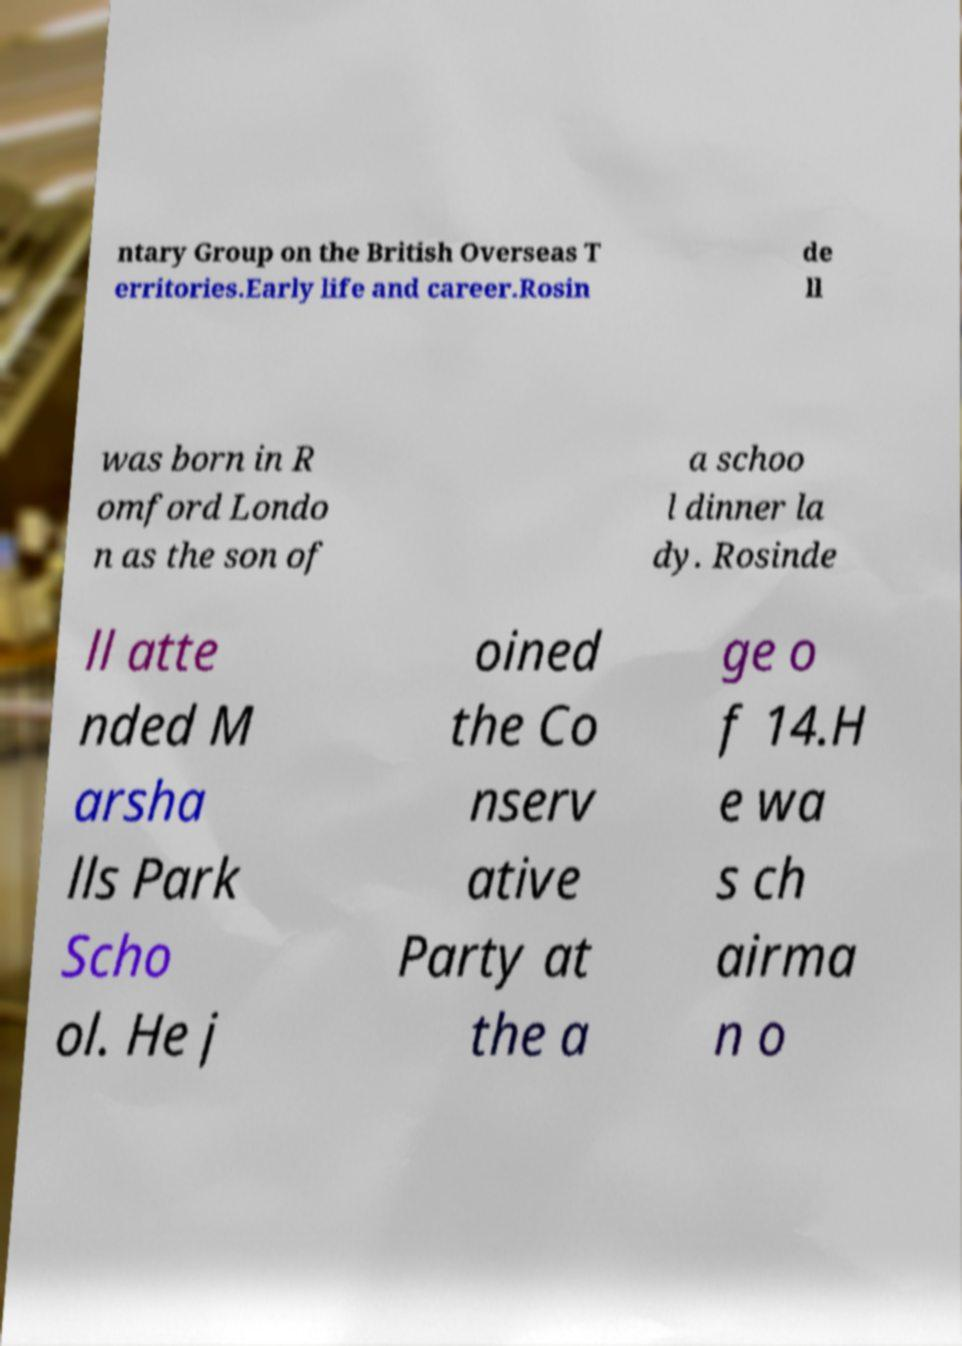Could you assist in decoding the text presented in this image and type it out clearly? ntary Group on the British Overseas T erritories.Early life and career.Rosin de ll was born in R omford Londo n as the son of a schoo l dinner la dy. Rosinde ll atte nded M arsha lls Park Scho ol. He j oined the Co nserv ative Party at the a ge o f 14.H e wa s ch airma n o 